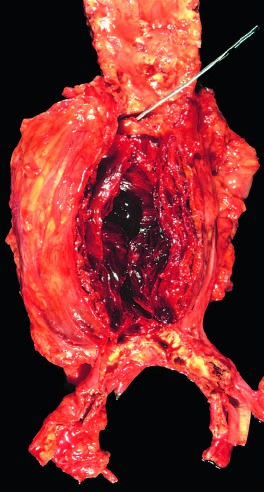s the wall of the aneurysm attenuated?
Answer the question using a single word or phrase. Yes 